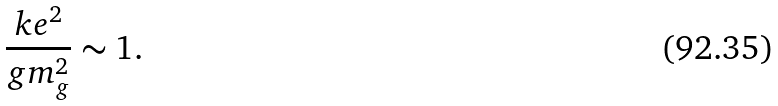<formula> <loc_0><loc_0><loc_500><loc_500>\frac { k e ^ { 2 } } { g m _ { g } ^ { 2 } } \sim 1 .</formula> 